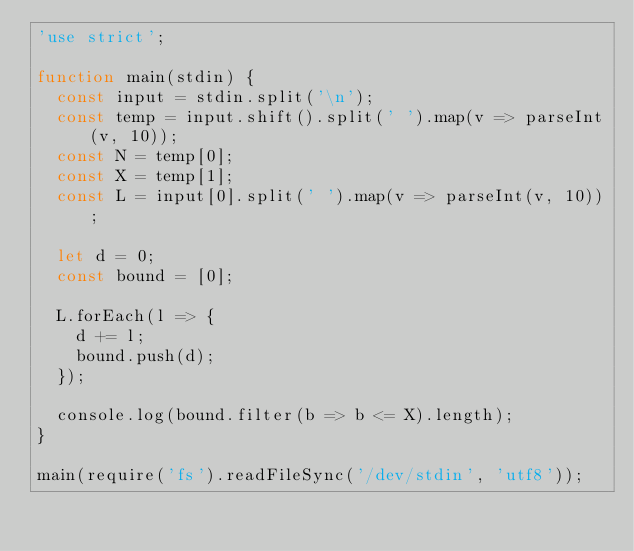Convert code to text. <code><loc_0><loc_0><loc_500><loc_500><_JavaScript_>'use strict';

function main(stdin) {
  const input = stdin.split('\n');
  const temp = input.shift().split(' ').map(v => parseInt(v, 10));
  const N = temp[0];
  const X = temp[1];
  const L = input[0].split(' ').map(v => parseInt(v, 10));

  let d = 0;
  const bound = [0];

  L.forEach(l => {
    d += l;
    bound.push(d);
  });
  
  console.log(bound.filter(b => b <= X).length);
}

main(require('fs').readFileSync('/dev/stdin', 'utf8'));</code> 